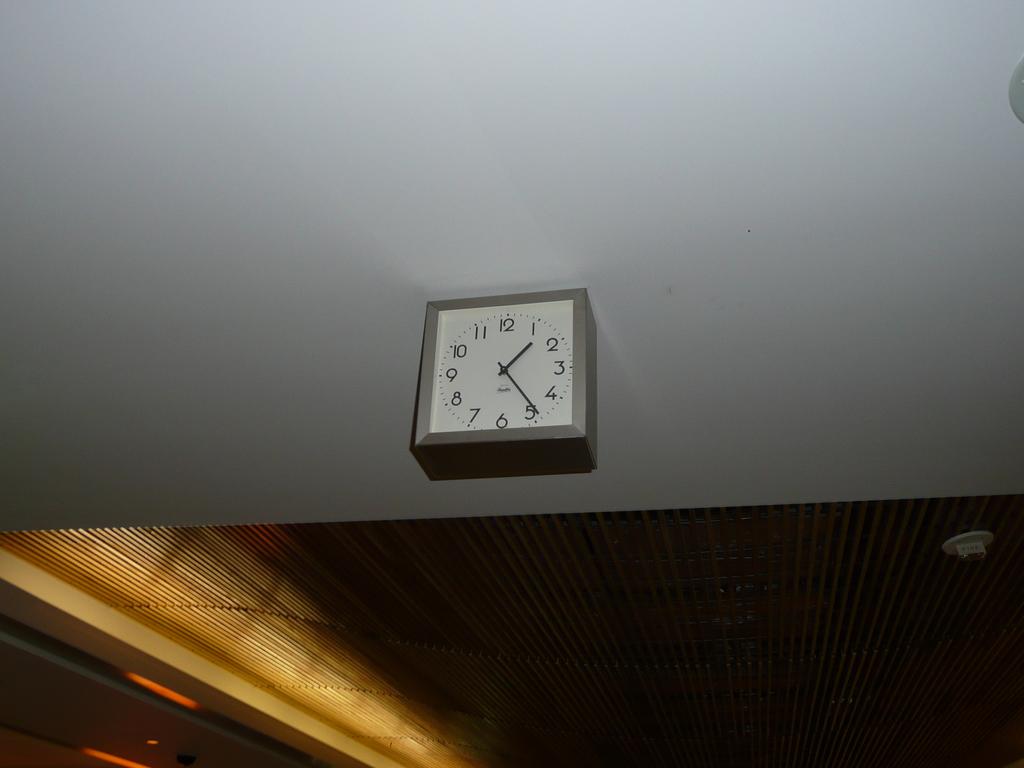What number is the bag hand pointing to on the clock?
Offer a terse response. 5. What time is shown on the clock?
Provide a succinct answer. 1:24. 